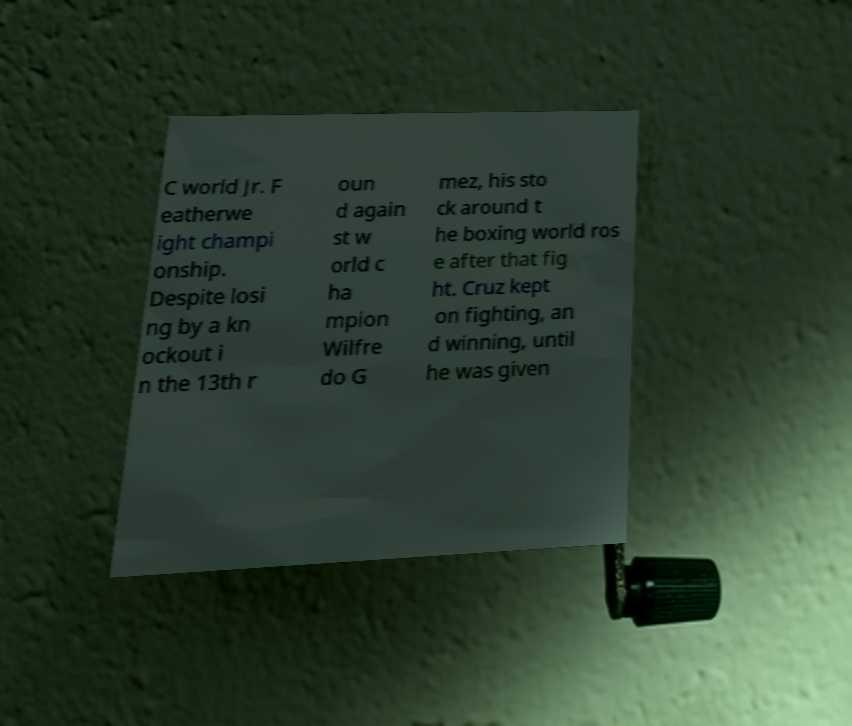For documentation purposes, I need the text within this image transcribed. Could you provide that? C world Jr. F eatherwe ight champi onship. Despite losi ng by a kn ockout i n the 13th r oun d again st w orld c ha mpion Wilfre do G mez, his sto ck around t he boxing world ros e after that fig ht. Cruz kept on fighting, an d winning, until he was given 